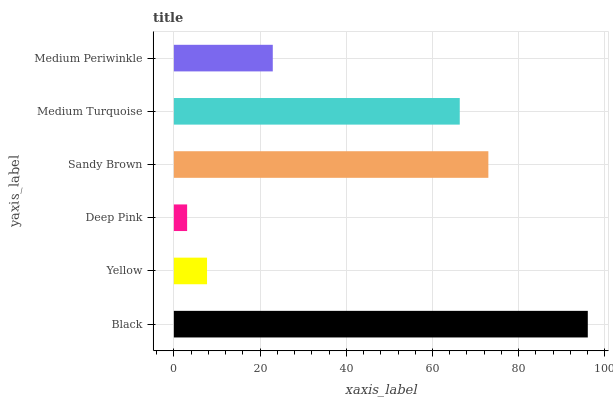Is Deep Pink the minimum?
Answer yes or no. Yes. Is Black the maximum?
Answer yes or no. Yes. Is Yellow the minimum?
Answer yes or no. No. Is Yellow the maximum?
Answer yes or no. No. Is Black greater than Yellow?
Answer yes or no. Yes. Is Yellow less than Black?
Answer yes or no. Yes. Is Yellow greater than Black?
Answer yes or no. No. Is Black less than Yellow?
Answer yes or no. No. Is Medium Turquoise the high median?
Answer yes or no. Yes. Is Medium Periwinkle the low median?
Answer yes or no. Yes. Is Medium Periwinkle the high median?
Answer yes or no. No. Is Sandy Brown the low median?
Answer yes or no. No. 